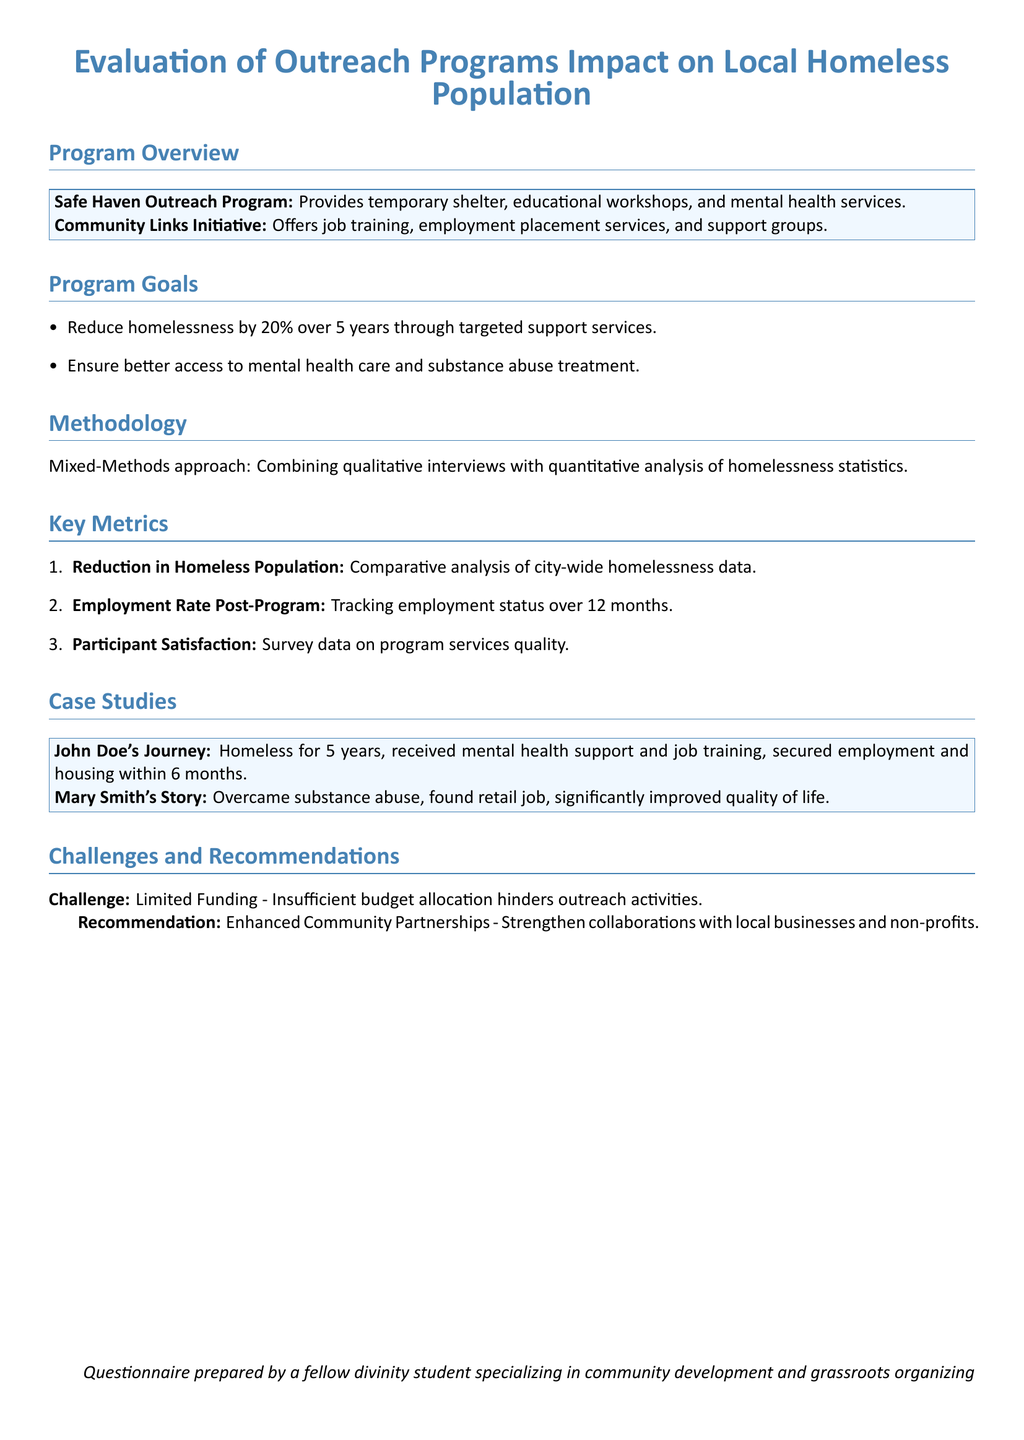What is the name of the outreach program that provides temporary shelter? The name of the outreach program that provides temporary shelter is mentioned in the program overview.
Answer: Safe Haven Outreach Program What is the reduction goal for homelessness over 5 years? The reduction goal for homelessness is stated clearly in the program goals section.
Answer: 20% What methodology is used for the evaluation? The methodology section describes the approach taken for the evaluation.
Answer: Mixed-Methods How many case studies are presented in the document? The number of case studies can be counted based on the case studies section.
Answer: 2 What is the challenge identified in the document? The challenge is explicitly mentioned in the challenges and recommendations section.
Answer: Limited Funding Which program focuses on job training and employment placement? The program that focuses on job training and employment placement is specified in the overview.
Answer: Community Links Initiative What metric is used to track participant satisfaction? The specific metric for participant satisfaction is outlined in the key metrics section.
Answer: Survey data What aspect improved in Mary Smith's life? The aspect of Mary Smith's life that improved is described in her case study.
Answer: Quality of life 